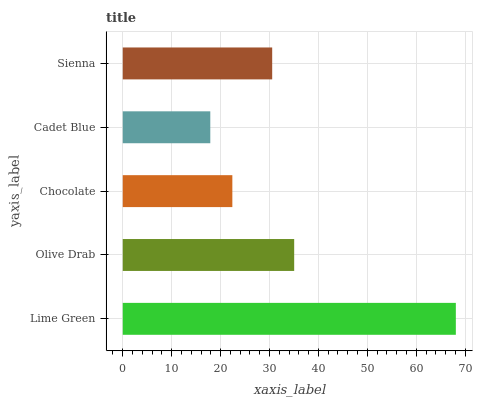Is Cadet Blue the minimum?
Answer yes or no. Yes. Is Lime Green the maximum?
Answer yes or no. Yes. Is Olive Drab the minimum?
Answer yes or no. No. Is Olive Drab the maximum?
Answer yes or no. No. Is Lime Green greater than Olive Drab?
Answer yes or no. Yes. Is Olive Drab less than Lime Green?
Answer yes or no. Yes. Is Olive Drab greater than Lime Green?
Answer yes or no. No. Is Lime Green less than Olive Drab?
Answer yes or no. No. Is Sienna the high median?
Answer yes or no. Yes. Is Sienna the low median?
Answer yes or no. Yes. Is Lime Green the high median?
Answer yes or no. No. Is Olive Drab the low median?
Answer yes or no. No. 